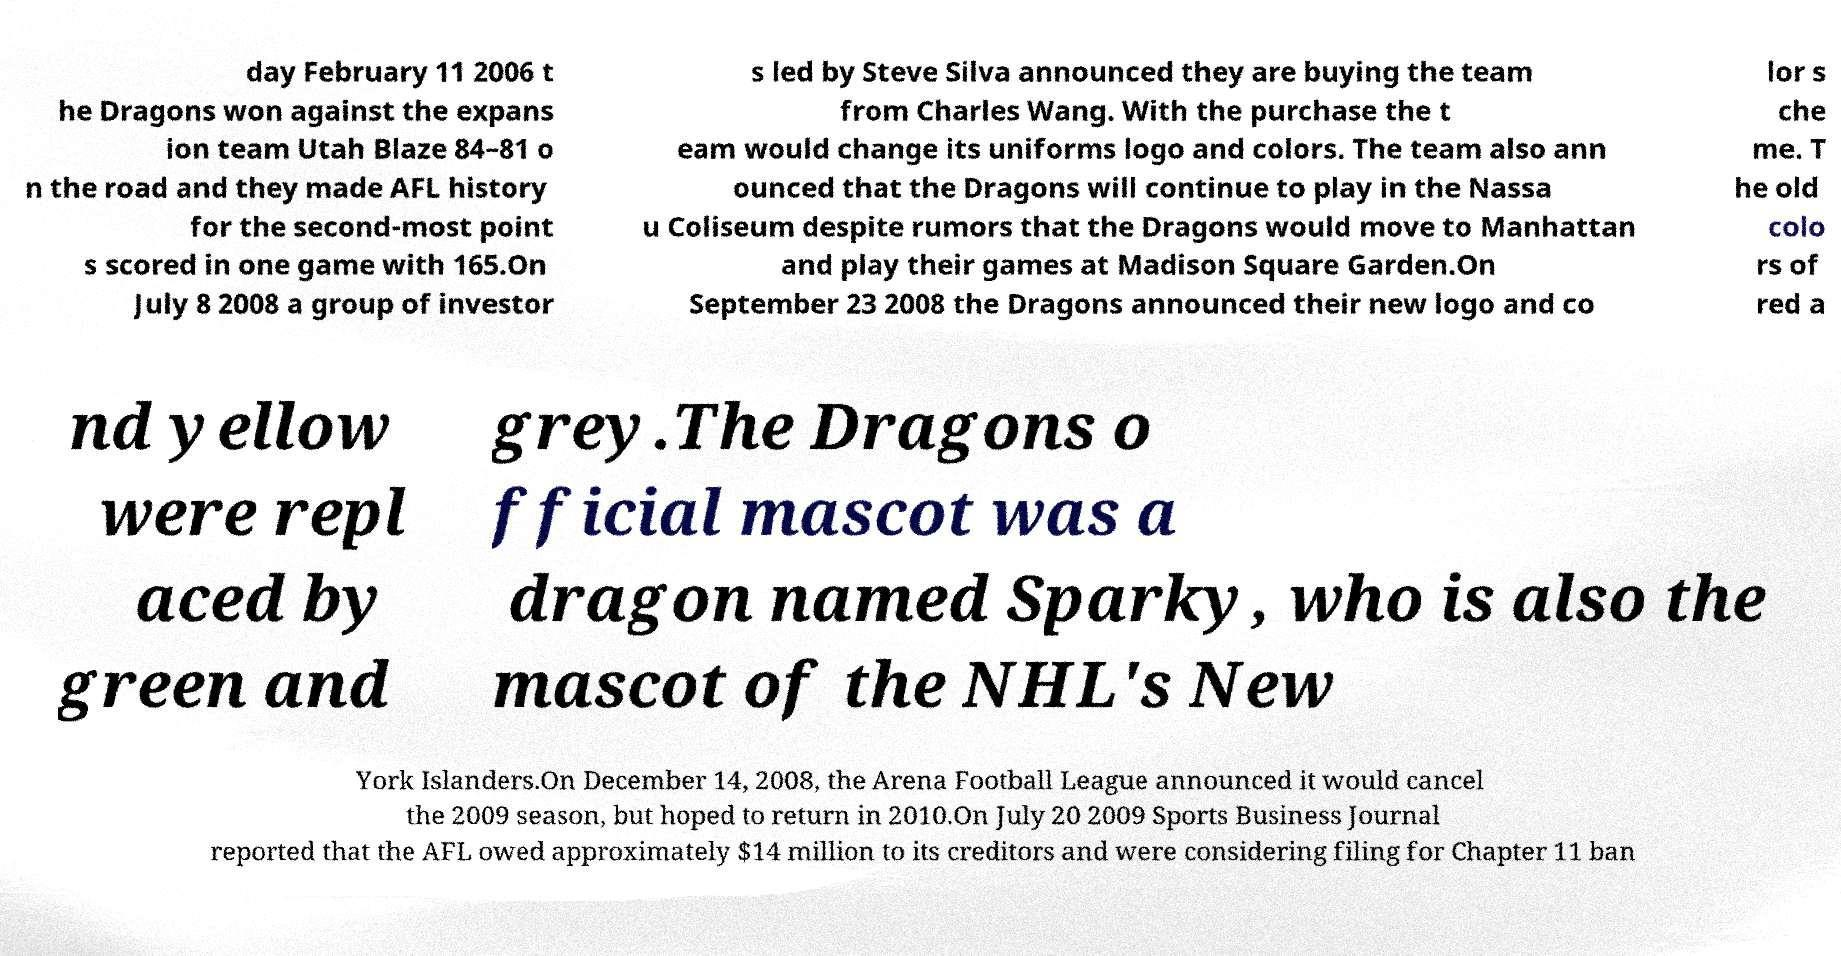Could you extract and type out the text from this image? day February 11 2006 t he Dragons won against the expans ion team Utah Blaze 84–81 o n the road and they made AFL history for the second-most point s scored in one game with 165.On July 8 2008 a group of investor s led by Steve Silva announced they are buying the team from Charles Wang. With the purchase the t eam would change its uniforms logo and colors. The team also ann ounced that the Dragons will continue to play in the Nassa u Coliseum despite rumors that the Dragons would move to Manhattan and play their games at Madison Square Garden.On September 23 2008 the Dragons announced their new logo and co lor s che me. T he old colo rs of red a nd yellow were repl aced by green and grey.The Dragons o fficial mascot was a dragon named Sparky, who is also the mascot of the NHL's New York Islanders.On December 14, 2008, the Arena Football League announced it would cancel the 2009 season, but hoped to return in 2010.On July 20 2009 Sports Business Journal reported that the AFL owed approximately $14 million to its creditors and were considering filing for Chapter 11 ban 